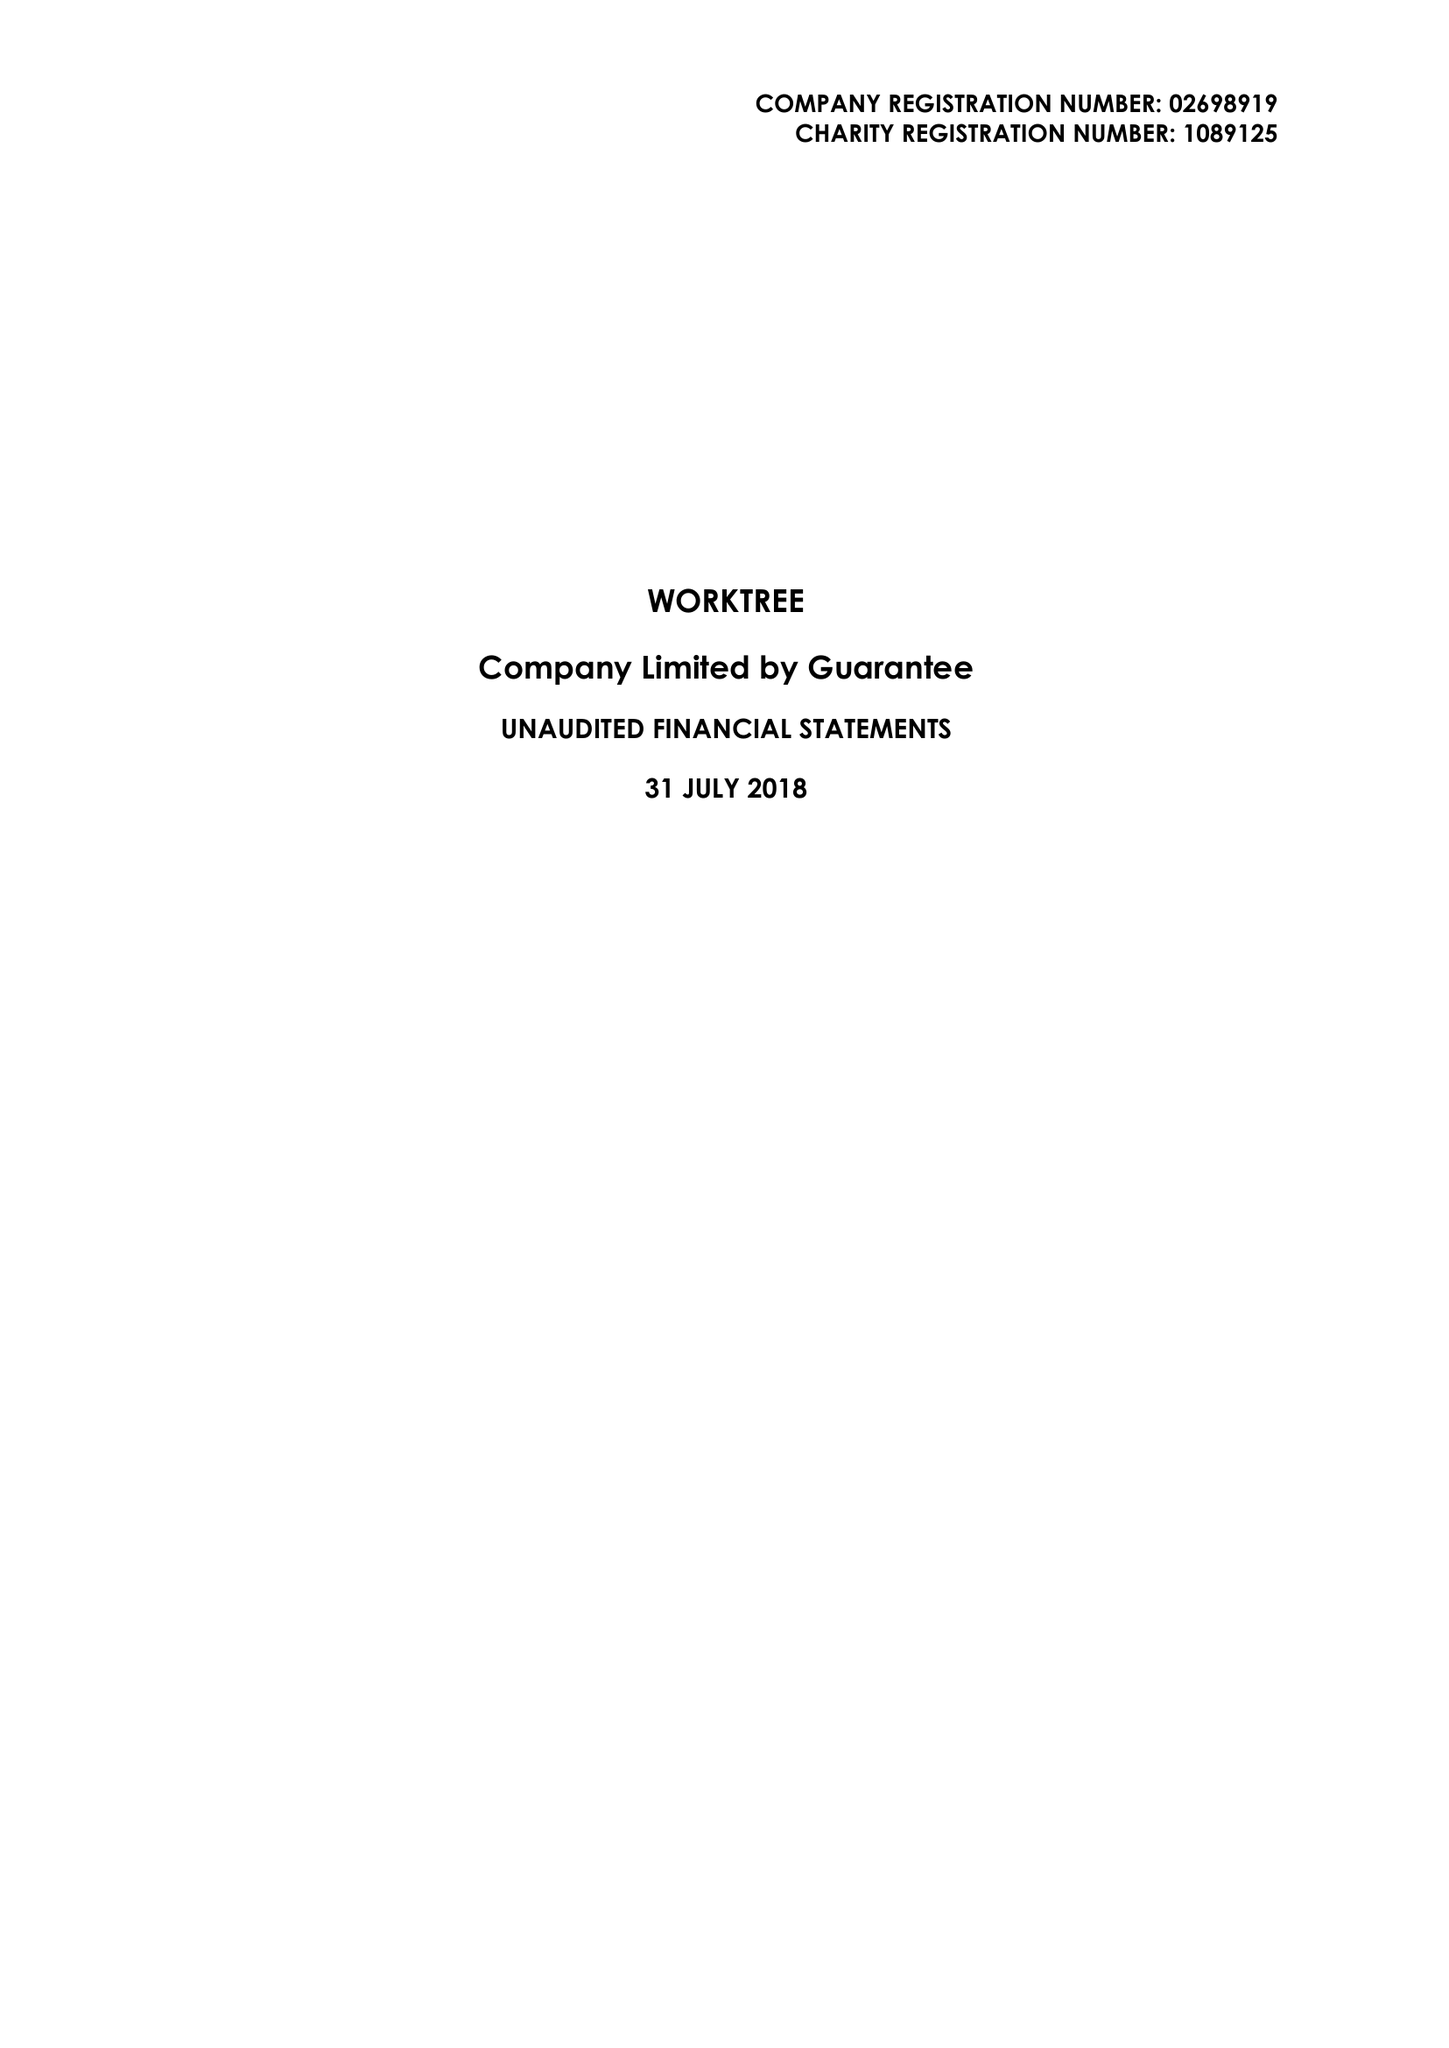What is the value for the report_date?
Answer the question using a single word or phrase. 2018-07-31 